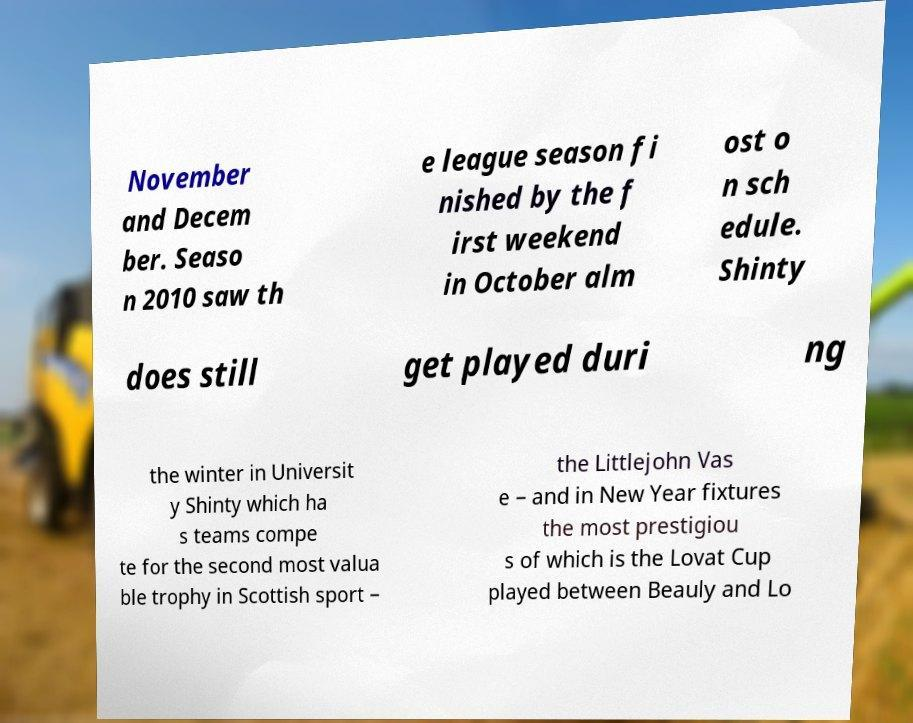I need the written content from this picture converted into text. Can you do that? November and Decem ber. Seaso n 2010 saw th e league season fi nished by the f irst weekend in October alm ost o n sch edule. Shinty does still get played duri ng the winter in Universit y Shinty which ha s teams compe te for the second most valua ble trophy in Scottish sport – the Littlejohn Vas e – and in New Year fixtures the most prestigiou s of which is the Lovat Cup played between Beauly and Lo 